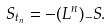Convert formula to latex. <formula><loc_0><loc_0><loc_500><loc_500>S _ { t _ { n } } = - ( L ^ { n } ) _ { - } S .</formula> 